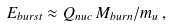Convert formula to latex. <formula><loc_0><loc_0><loc_500><loc_500>E _ { b u r s t } \approx Q _ { n u c } \, M _ { b u r n } / m _ { u } \, ,</formula> 